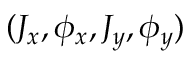<formula> <loc_0><loc_0><loc_500><loc_500>( J _ { x } , \phi _ { x } , J _ { y } , \phi _ { y } )</formula> 